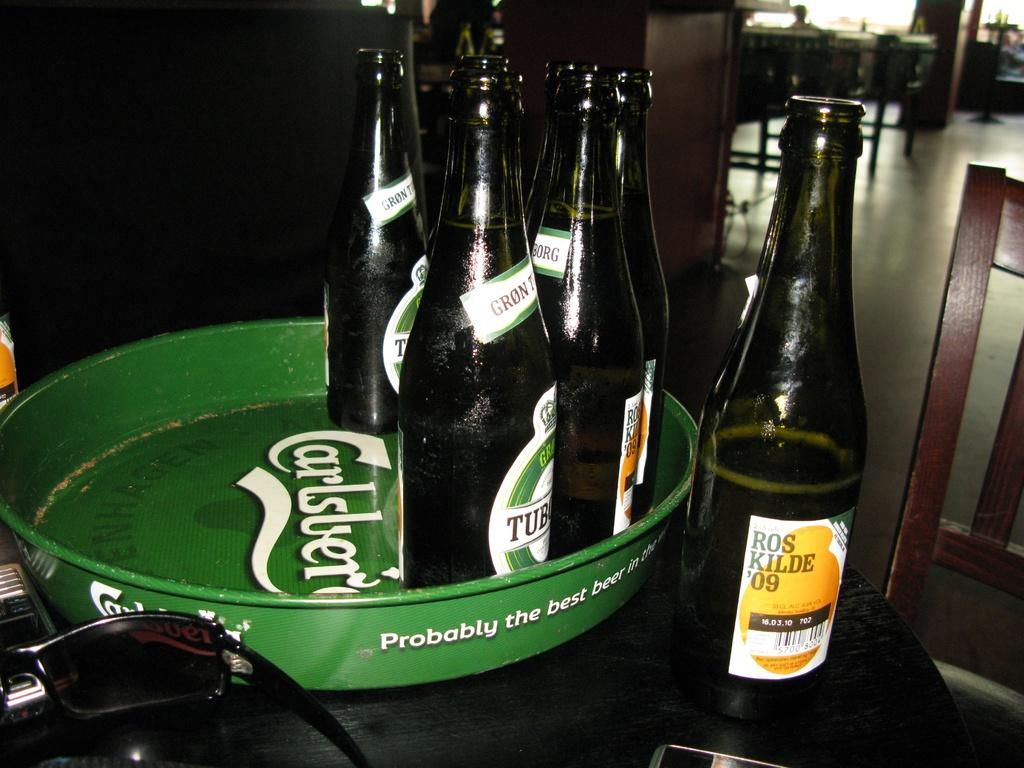<image>
Describe the image concisely. A tray that says Carlsberg has bottles of beer on it. 